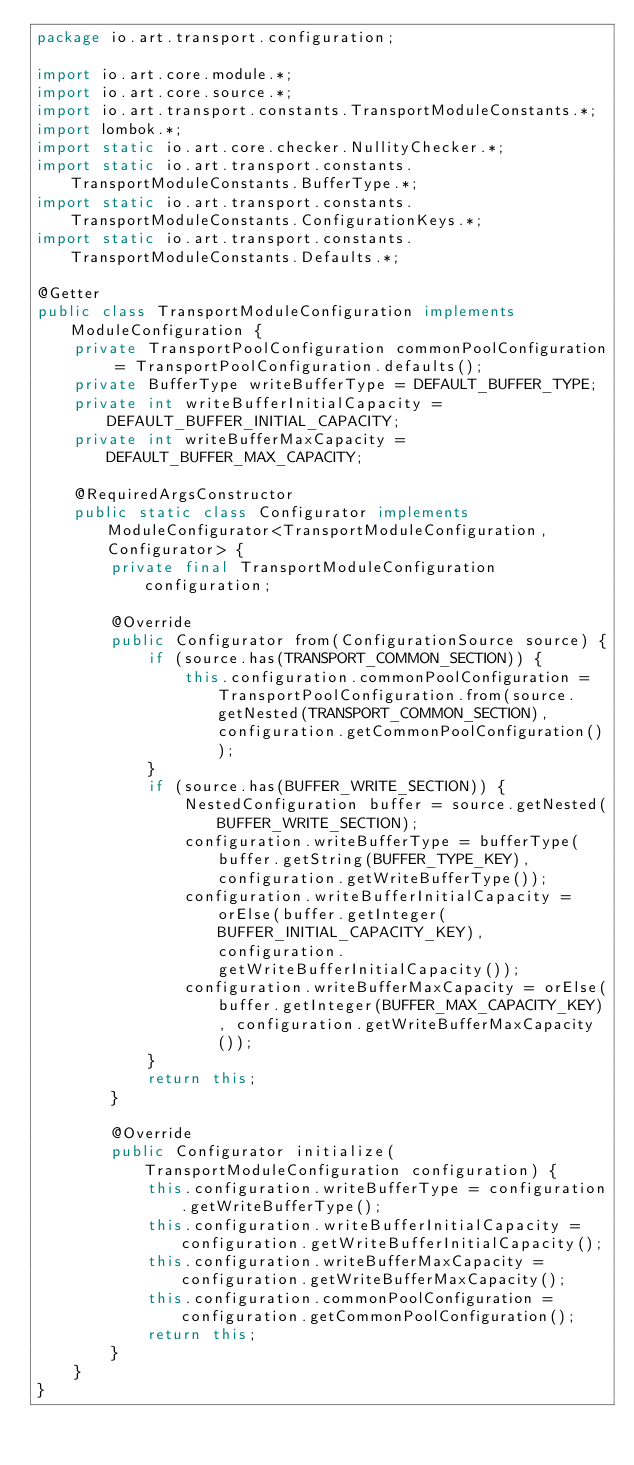<code> <loc_0><loc_0><loc_500><loc_500><_Java_>package io.art.transport.configuration;

import io.art.core.module.*;
import io.art.core.source.*;
import io.art.transport.constants.TransportModuleConstants.*;
import lombok.*;
import static io.art.core.checker.NullityChecker.*;
import static io.art.transport.constants.TransportModuleConstants.BufferType.*;
import static io.art.transport.constants.TransportModuleConstants.ConfigurationKeys.*;
import static io.art.transport.constants.TransportModuleConstants.Defaults.*;

@Getter
public class TransportModuleConfiguration implements ModuleConfiguration {
    private TransportPoolConfiguration commonPoolConfiguration = TransportPoolConfiguration.defaults();
    private BufferType writeBufferType = DEFAULT_BUFFER_TYPE;
    private int writeBufferInitialCapacity = DEFAULT_BUFFER_INITIAL_CAPACITY;
    private int writeBufferMaxCapacity = DEFAULT_BUFFER_MAX_CAPACITY;

    @RequiredArgsConstructor
    public static class Configurator implements ModuleConfigurator<TransportModuleConfiguration, Configurator> {
        private final TransportModuleConfiguration configuration;

        @Override
        public Configurator from(ConfigurationSource source) {
            if (source.has(TRANSPORT_COMMON_SECTION)) {
                this.configuration.commonPoolConfiguration = TransportPoolConfiguration.from(source.getNested(TRANSPORT_COMMON_SECTION), configuration.getCommonPoolConfiguration());
            }
            if (source.has(BUFFER_WRITE_SECTION)) {
                NestedConfiguration buffer = source.getNested(BUFFER_WRITE_SECTION);
                configuration.writeBufferType = bufferType(buffer.getString(BUFFER_TYPE_KEY), configuration.getWriteBufferType());
                configuration.writeBufferInitialCapacity = orElse(buffer.getInteger(BUFFER_INITIAL_CAPACITY_KEY), configuration.getWriteBufferInitialCapacity());
                configuration.writeBufferMaxCapacity = orElse(buffer.getInteger(BUFFER_MAX_CAPACITY_KEY), configuration.getWriteBufferMaxCapacity());
            }
            return this;
        }

        @Override
        public Configurator initialize(TransportModuleConfiguration configuration) {
            this.configuration.writeBufferType = configuration.getWriteBufferType();
            this.configuration.writeBufferInitialCapacity = configuration.getWriteBufferInitialCapacity();
            this.configuration.writeBufferMaxCapacity = configuration.getWriteBufferMaxCapacity();
            this.configuration.commonPoolConfiguration = configuration.getCommonPoolConfiguration();
            return this;
        }
    }
}
</code> 